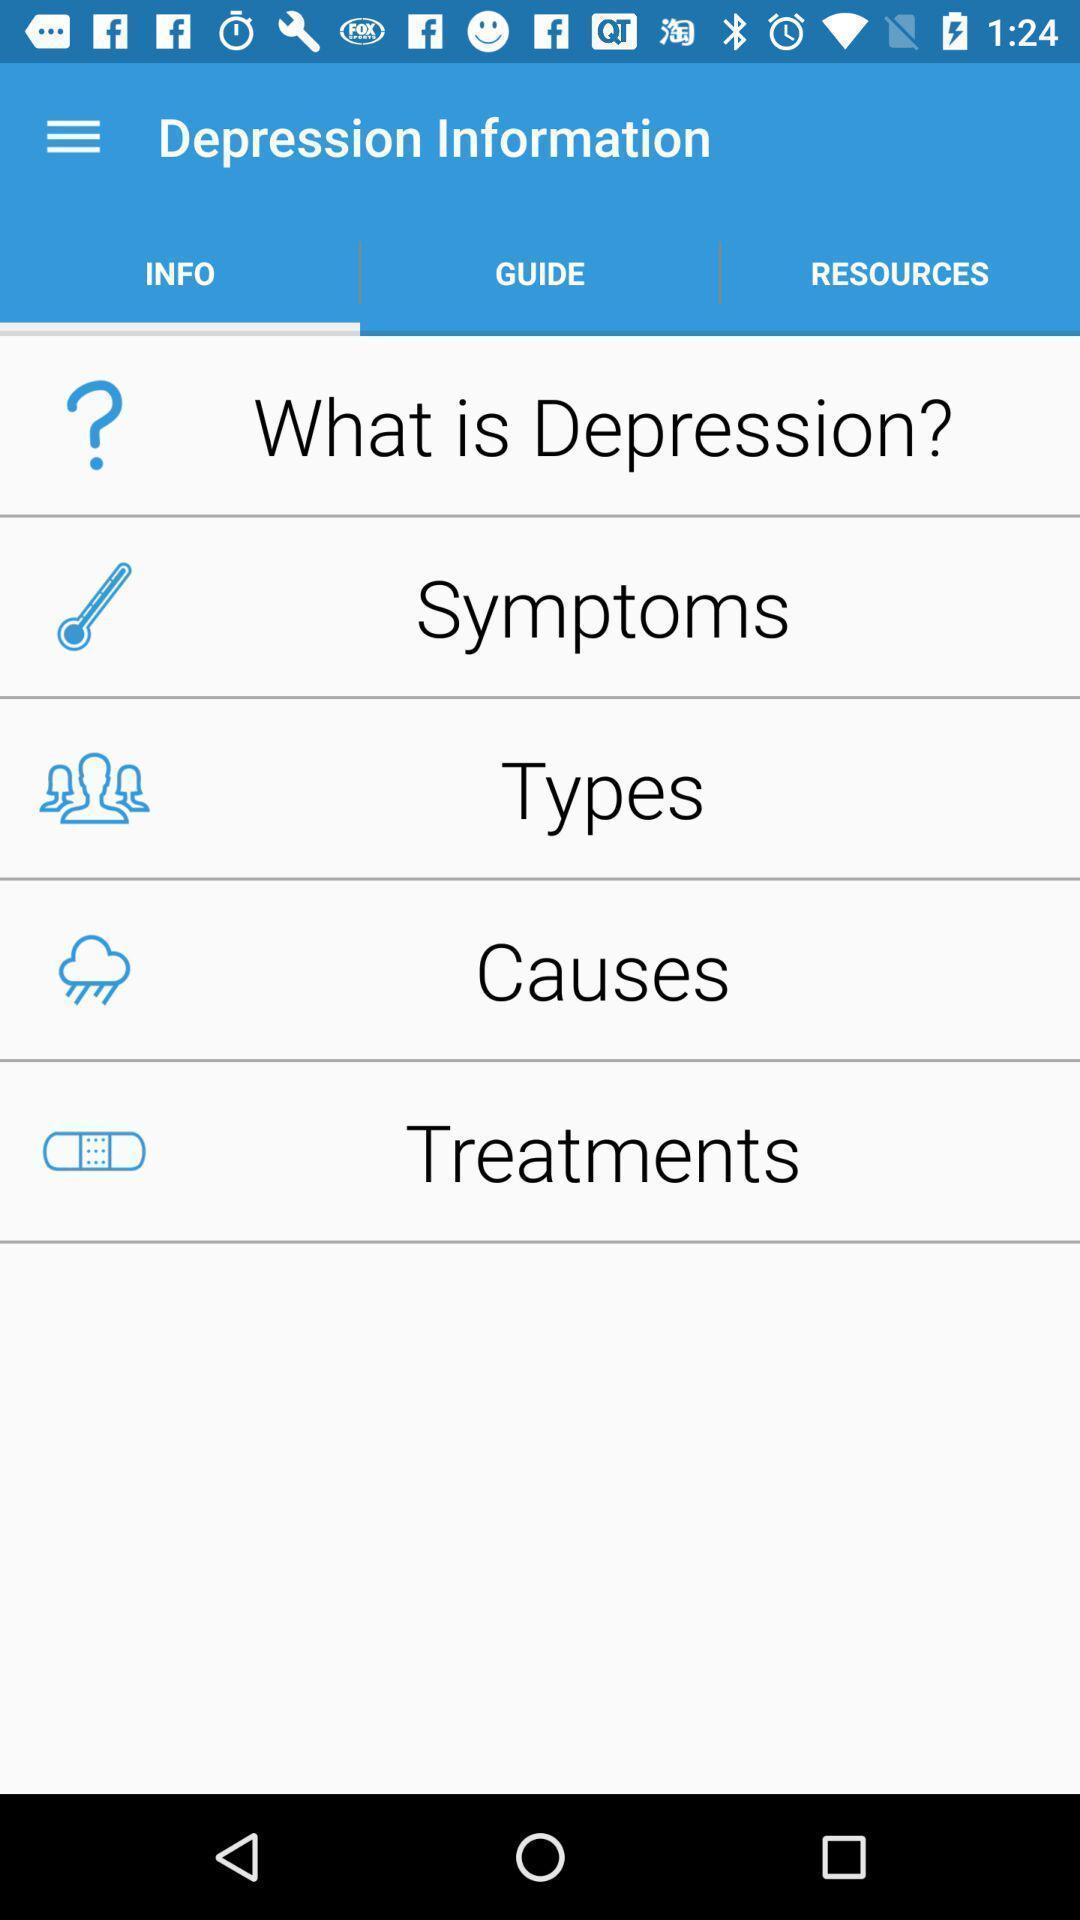Tell me what you see in this picture. Screen displaying multiple options. 